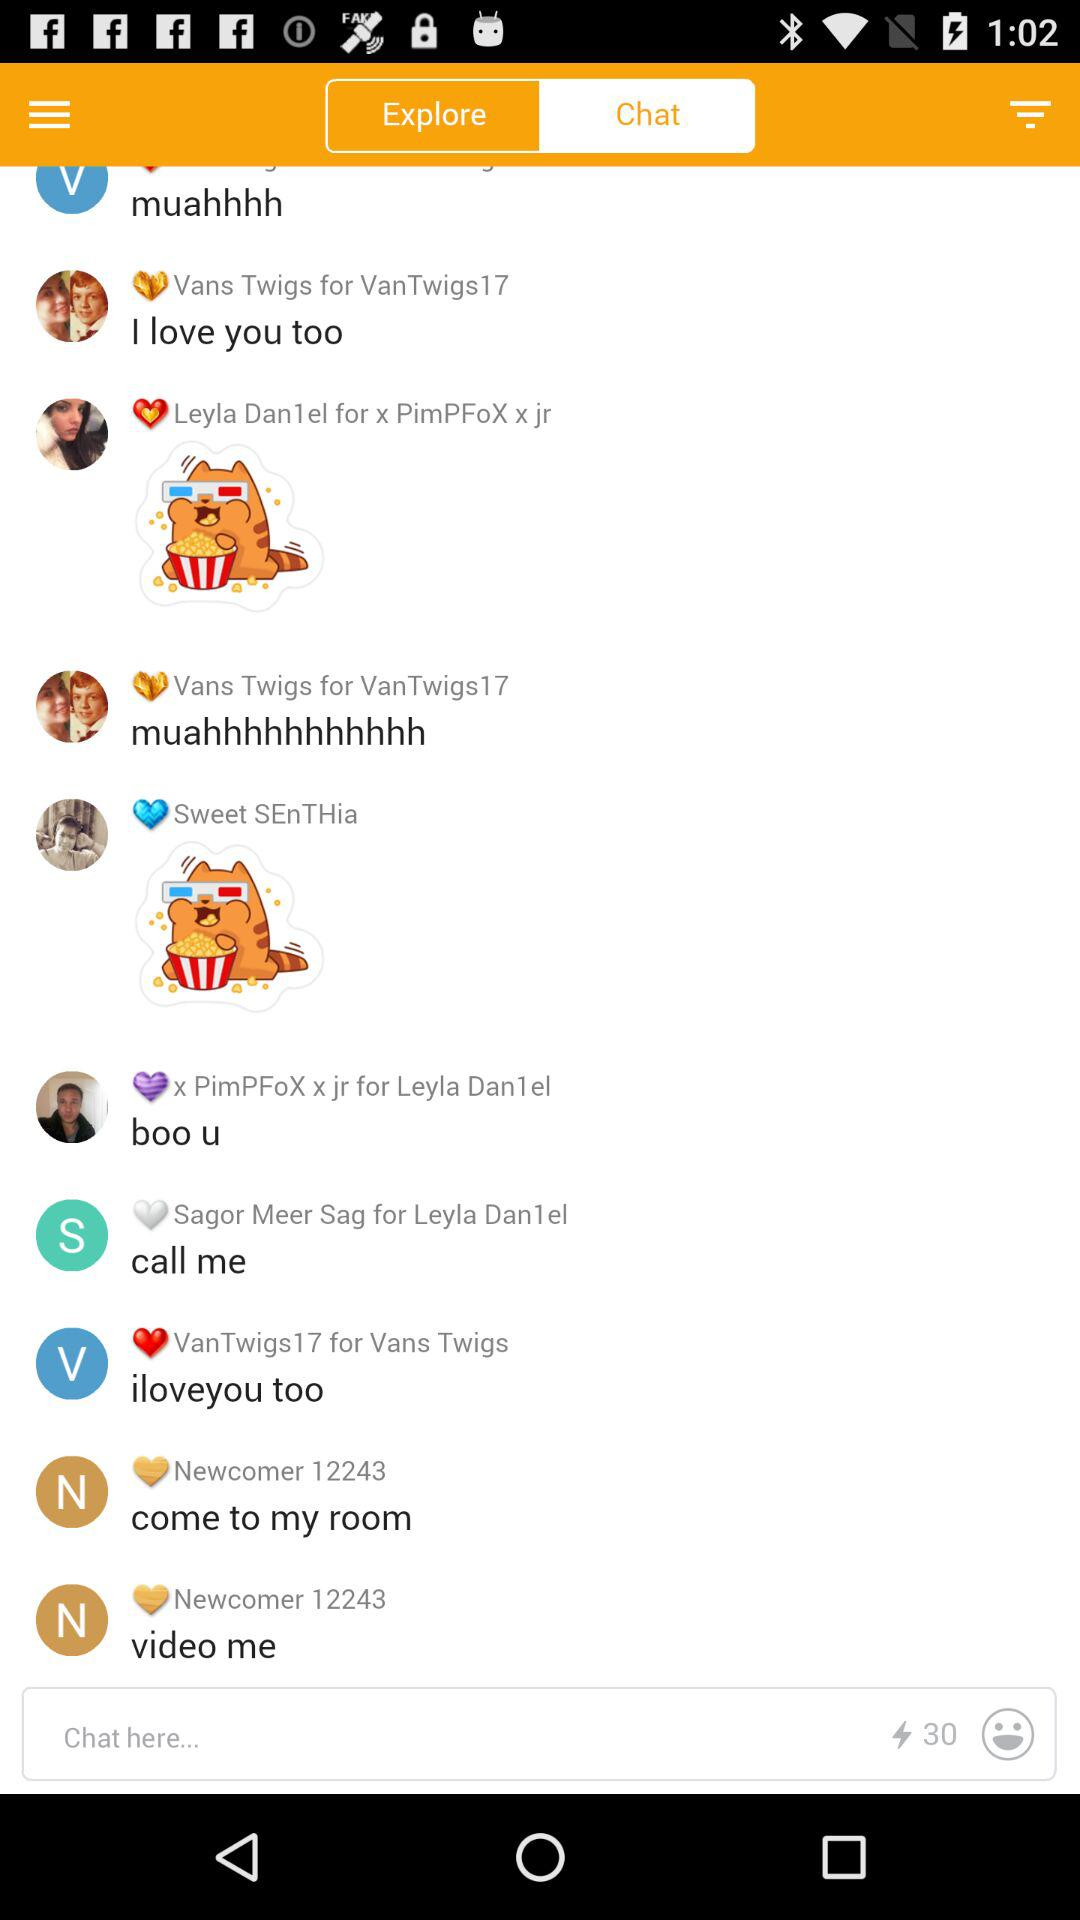When did this chat begin?
When the provided information is insufficient, respond with <no answer>. <no answer> 